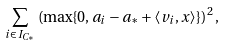Convert formula to latex. <formula><loc_0><loc_0><loc_500><loc_500>\sum _ { i \in I _ { C _ { \ast } } } \left ( \max \{ 0 , a _ { i } - a _ { \ast } + \langle v _ { i } , x \rangle \} \right ) ^ { 2 } ,</formula> 